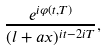<formula> <loc_0><loc_0><loc_500><loc_500>\frac { e ^ { i \varphi ( t , T ) } } { ( l + a x ) ^ { i t - 2 i T } } ,</formula> 